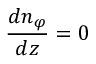Convert formula to latex. <formula><loc_0><loc_0><loc_500><loc_500>{ \frac { d n _ { \varphi } } { d z } } = 0</formula> 